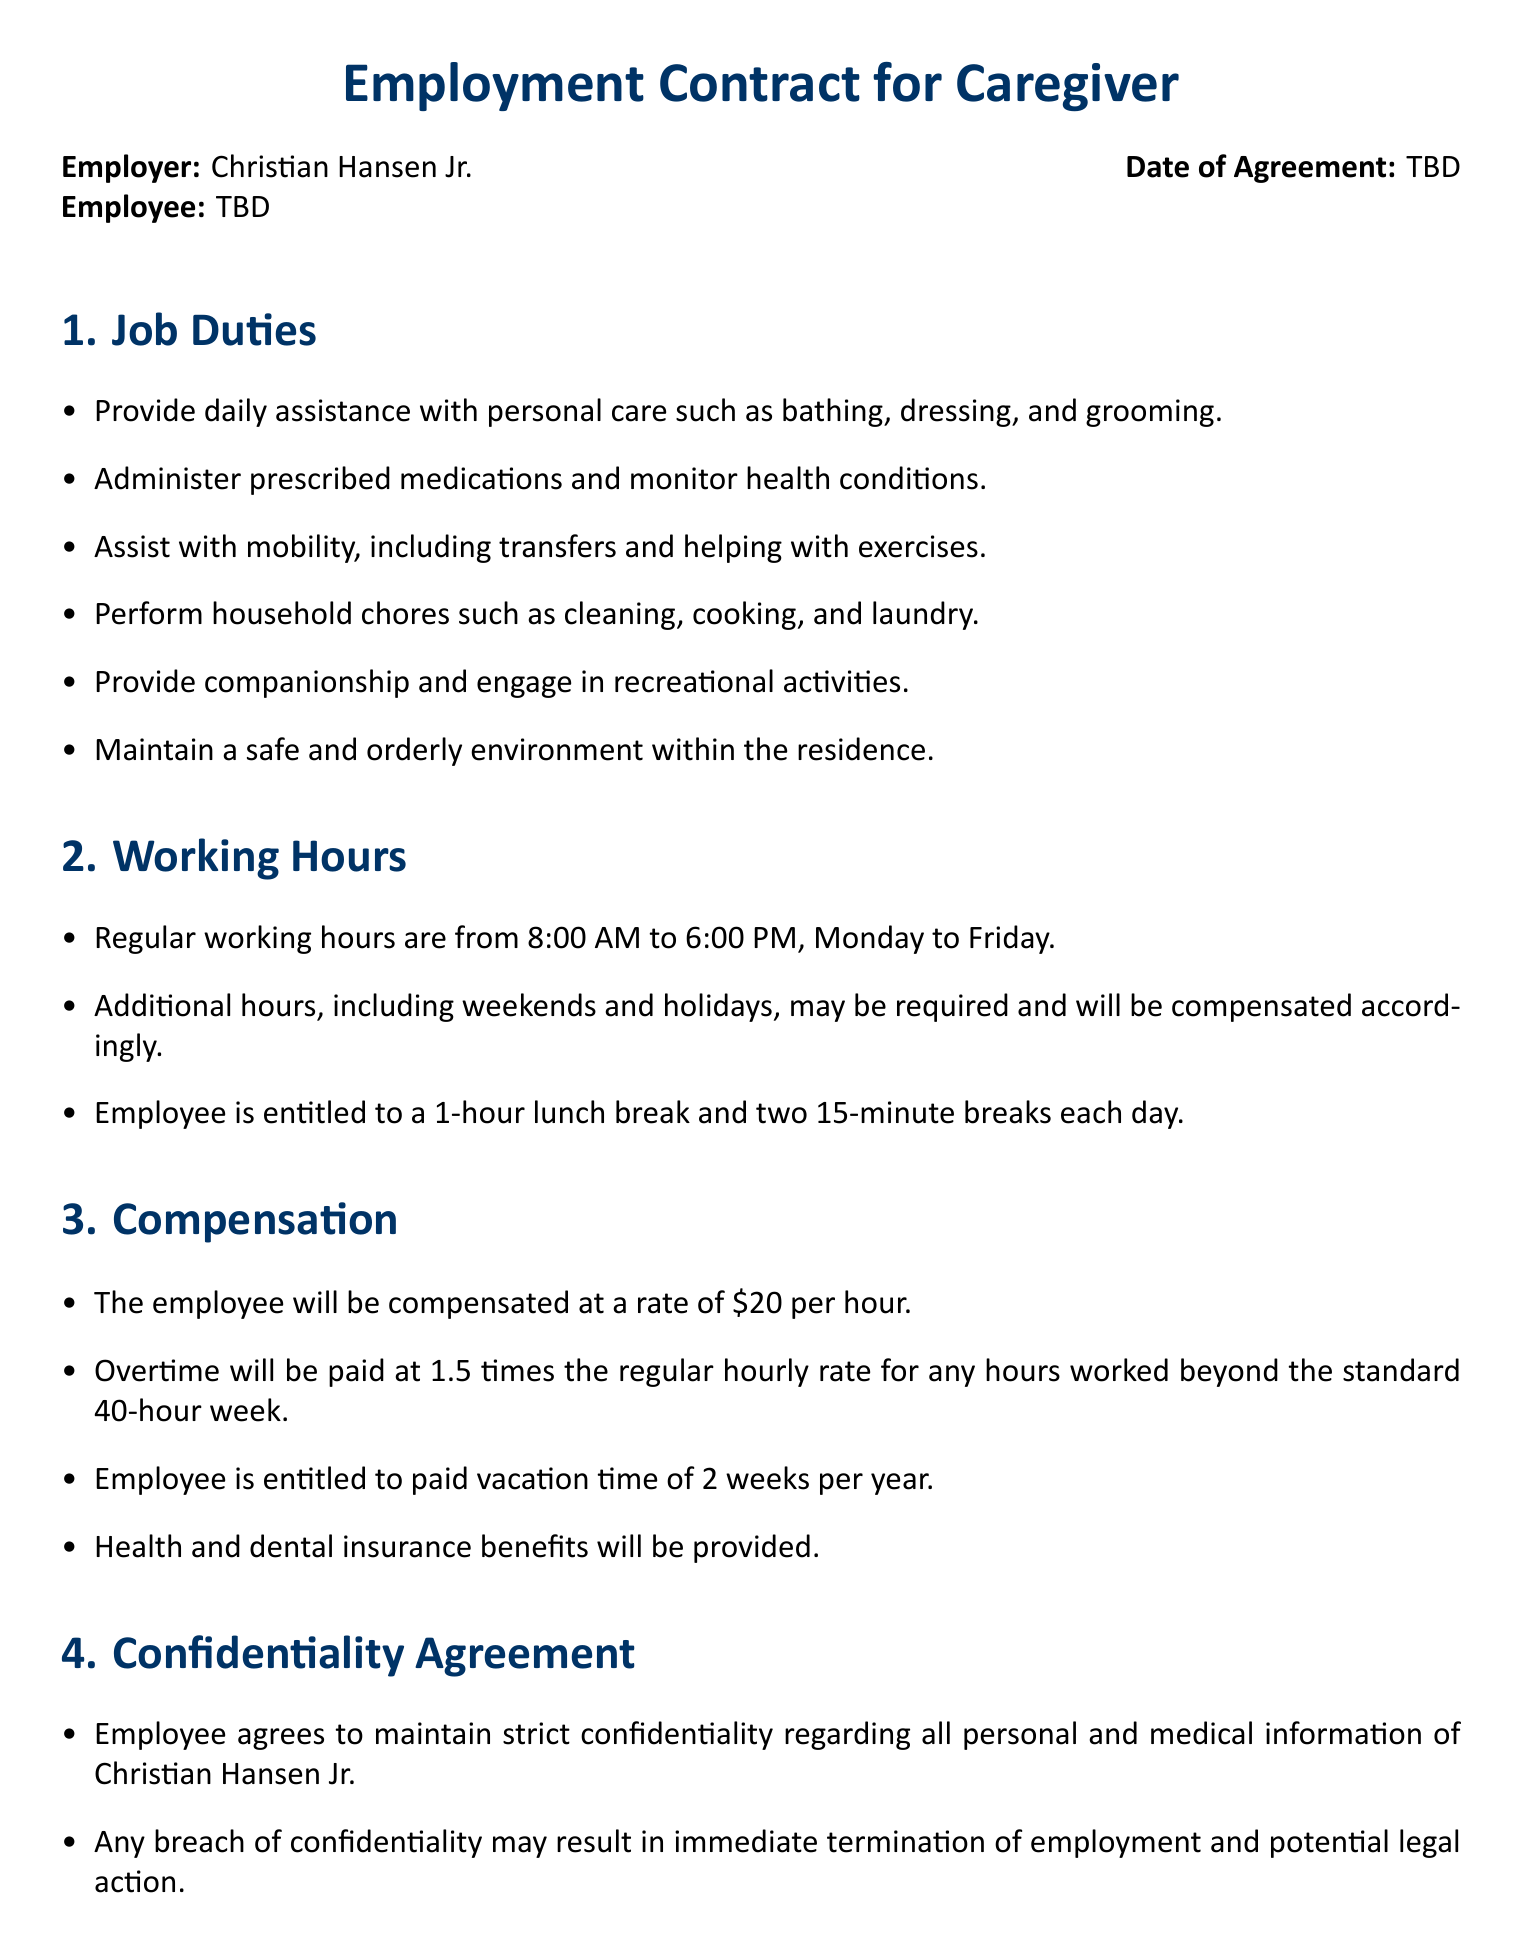What is the date of the agreement? The date of the agreement is indicated as "TBD" in the document.
Answer: TBD What is the hourly compensation rate? The compensation section states the employee will be compensated at a rate of $20 per hour.
Answer: $20 What are the regular working hours? The working hours section specifies that regular working hours are from 8:00 AM to 6:00 PM, Monday to Friday.
Answer: 8:00 AM to 6:00 PM, Monday to Friday How many weeks of paid vacation is the employee entitled to per year? The compensation section states that the employee is entitled to 2 weeks of paid vacation time per year.
Answer: 2 weeks What is the overtime pay rate for hours beyond 40 per week? The compensation section indicates that overtime will be paid at 1.5 times the regular hourly rate.
Answer: 1.5 times What are the consequences of breaching confidentiality? The confidentiality agreement states that a breach may result in immediate termination and potential legal action.
Answer: Immediate termination and potential legal action What types of insurance benefits will be provided? The compensation section mentions health and dental insurance benefits will be provided.
Answer: Health and dental insurance What personal care tasks is the employee expected to assist with? The job duties section lists tasks such as bathing, dressing, and grooming as personal care responsibilities.
Answer: Bathing, dressing, and grooming How many breaks is the employee entitled to each day? The working hours section states the employee is entitled to two 15-minute breaks each day.
Answer: Two 15-minute breaks 